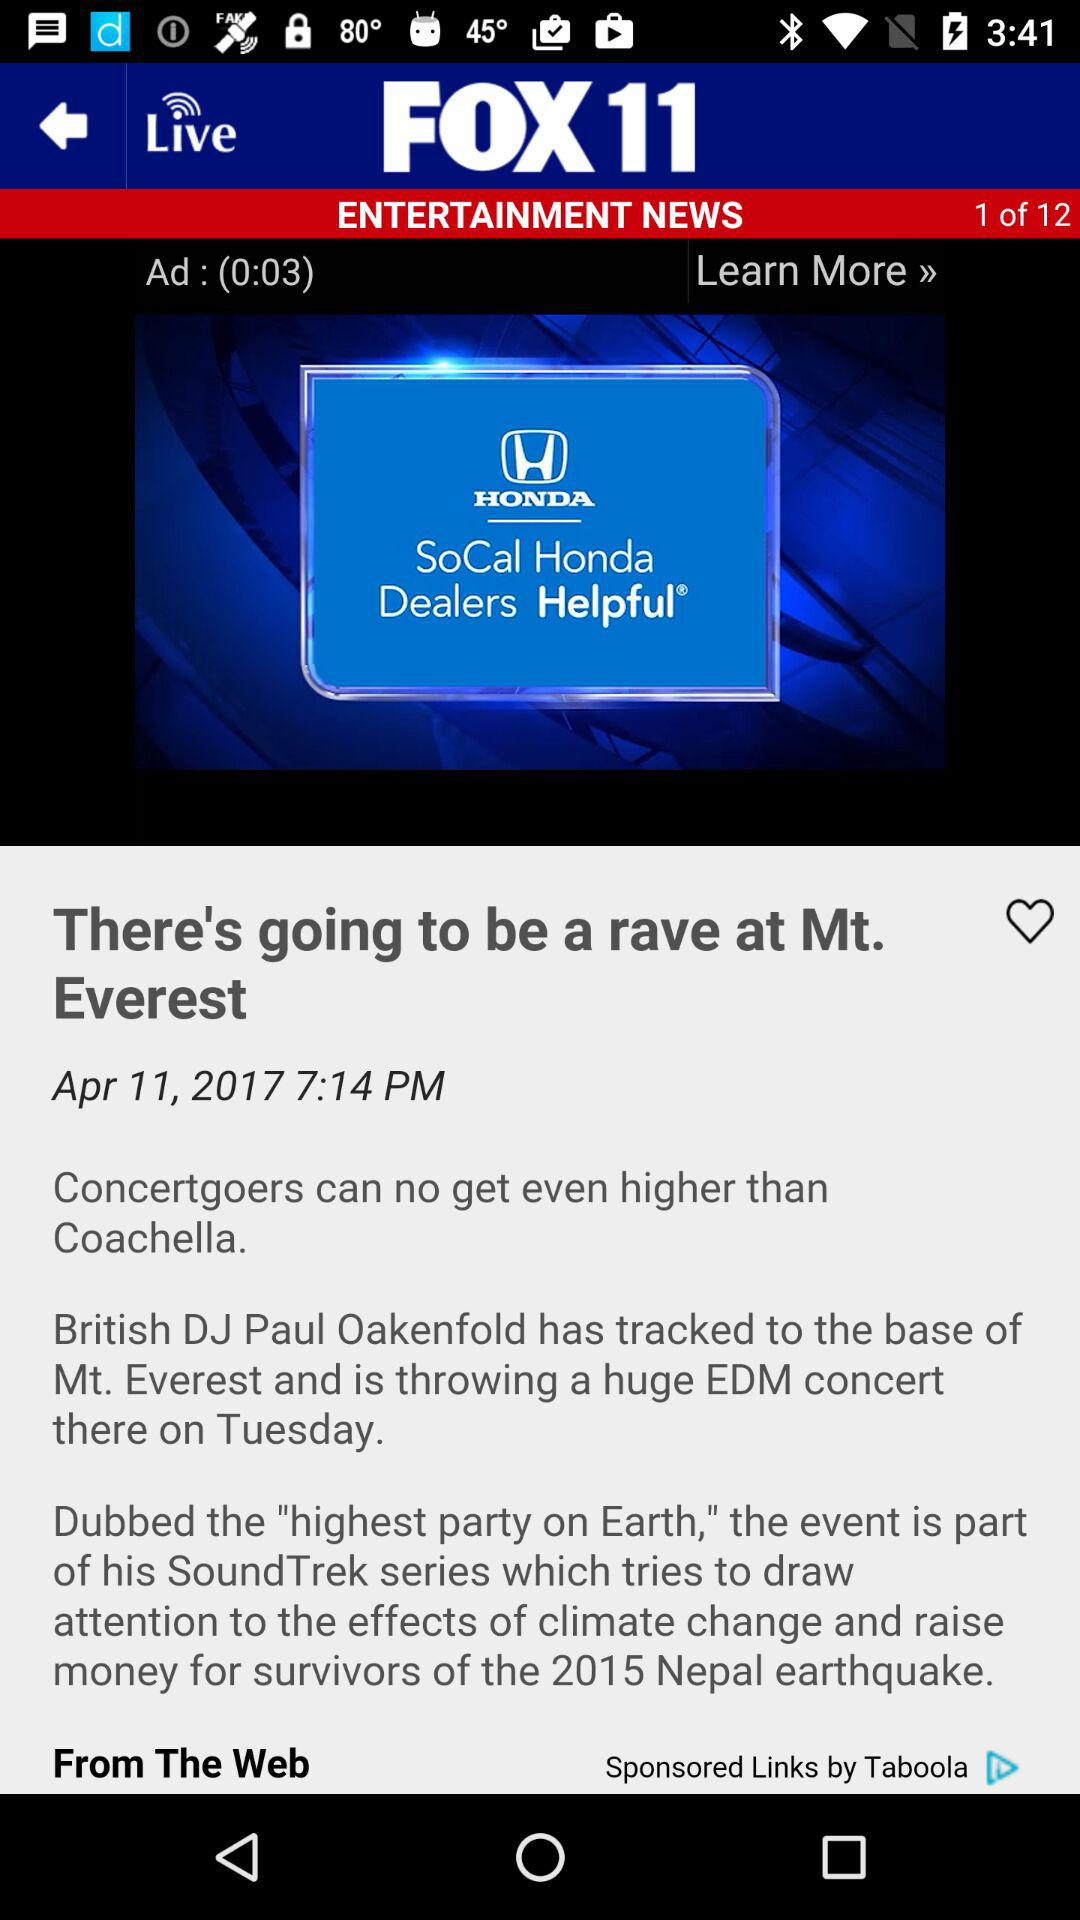What is the name of the application? The name of the application is "FOX 11". 